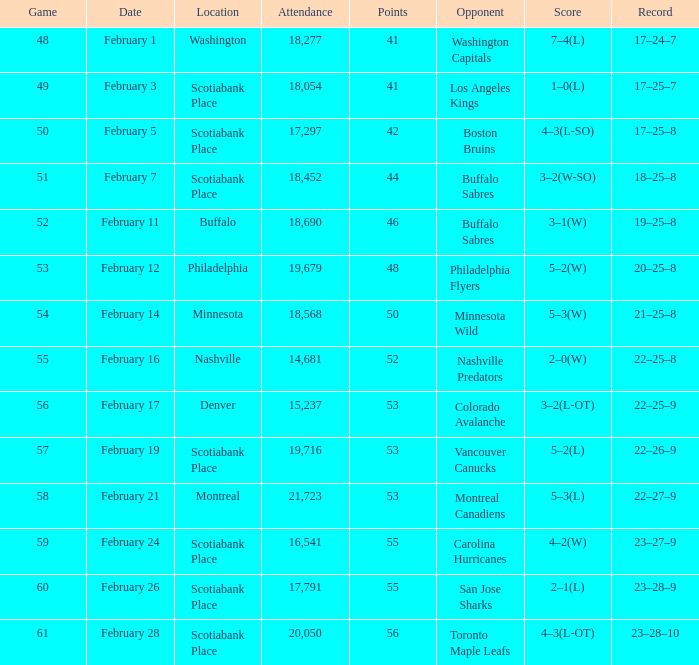What sum of game has an attendance of 18,690? 52.0. 